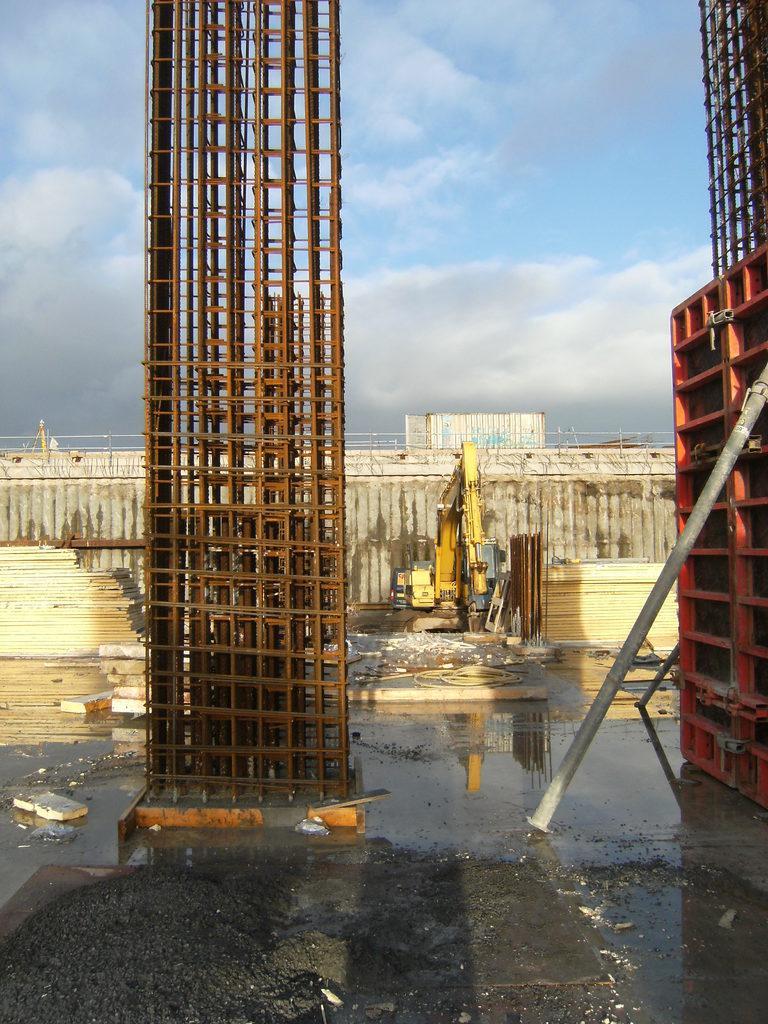Describe this image in one or two sentences. Sky is cloudy. This are rods. This is a crane. Surface is with water. 